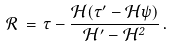Convert formula to latex. <formula><loc_0><loc_0><loc_500><loc_500>\mathcal { R } \, = \, \tau - \frac { \mathcal { H } ( \tau ^ { \prime } - \mathcal { H } \psi ) } { \mathcal { H } ^ { \prime } - \mathcal { H } ^ { 2 } } \, .</formula> 